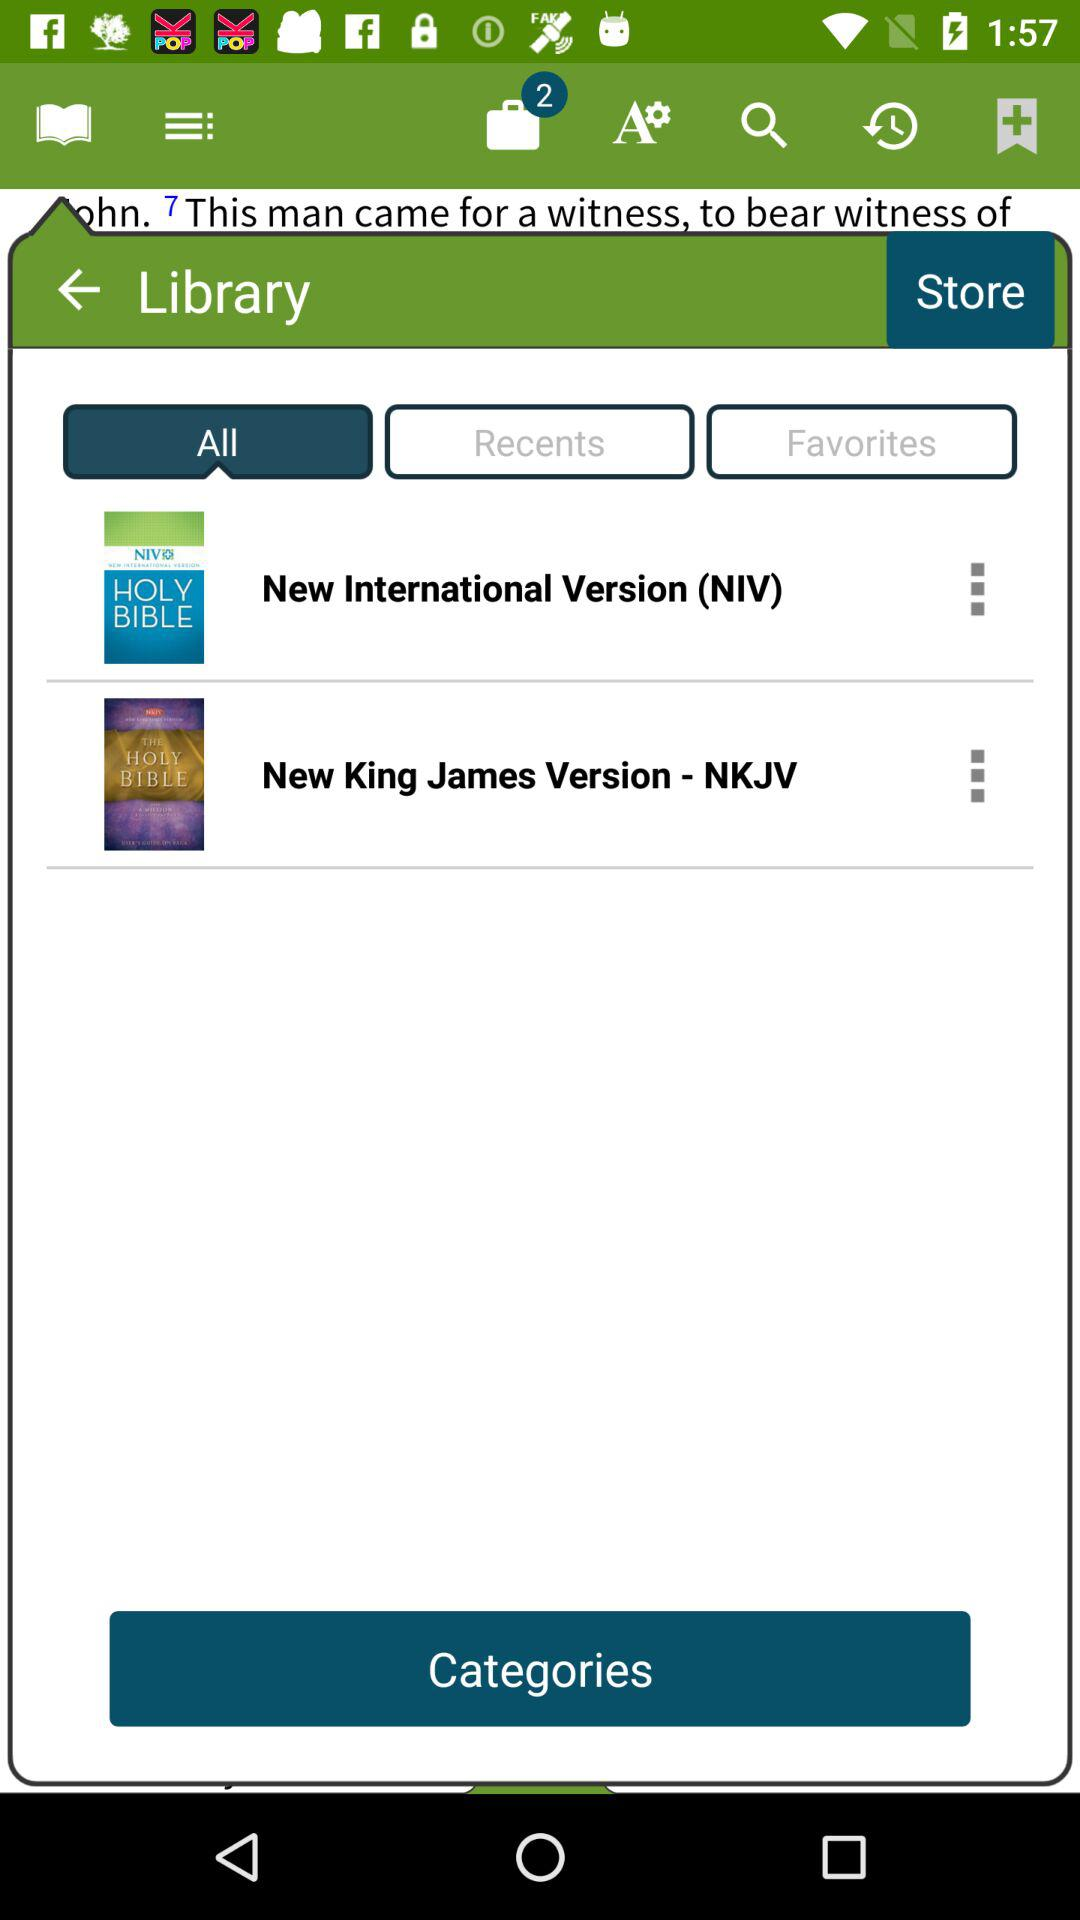Which tab am I using? You are using the "All" tab. 